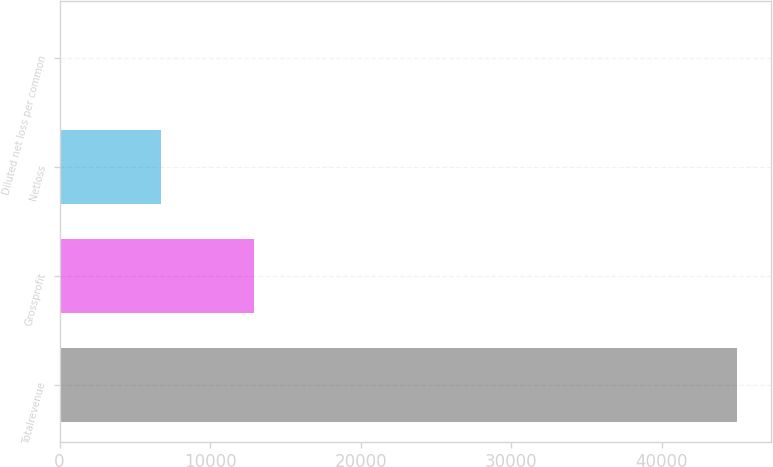Convert chart. <chart><loc_0><loc_0><loc_500><loc_500><bar_chart><fcel>Totalrevenue<fcel>Grossprofit<fcel>Netloss<fcel>Diluted net loss per common<nl><fcel>44978<fcel>12907<fcel>6765<fcel>0.44<nl></chart> 